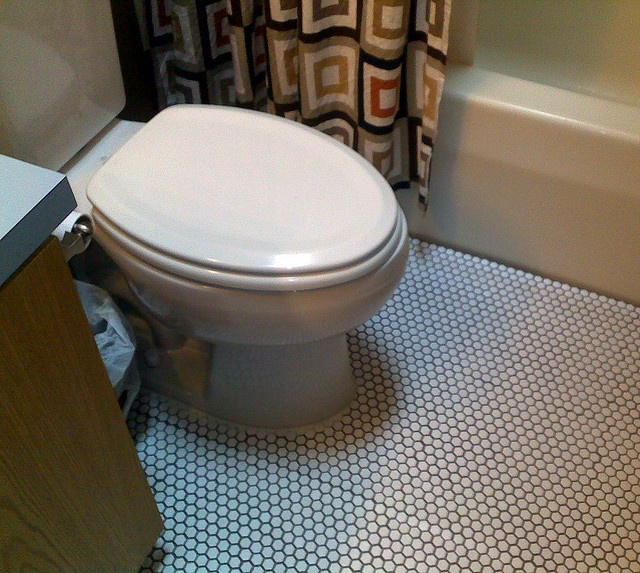Describe the objects in this image and their specific colors. I can see a toilet in brown, lightgray, gray, black, and darkgray tones in this image. 